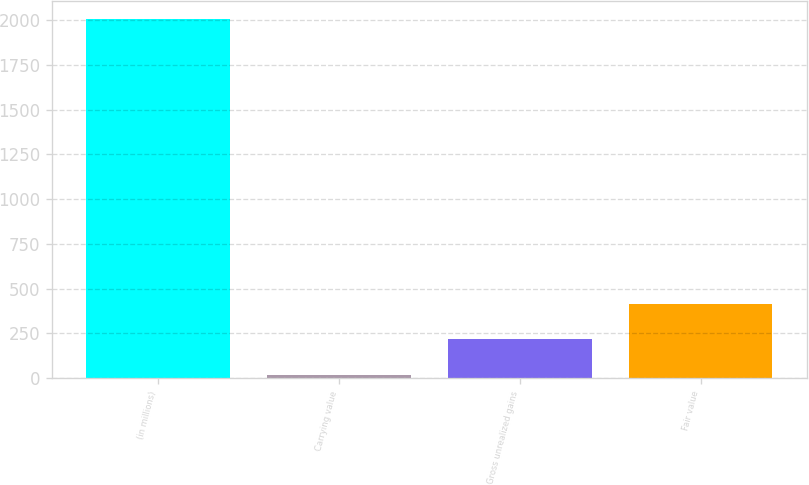<chart> <loc_0><loc_0><loc_500><loc_500><bar_chart><fcel>(in millions)<fcel>Carrying value<fcel>Gross unrealized gains<fcel>Fair value<nl><fcel>2007<fcel>18<fcel>216.9<fcel>415.8<nl></chart> 